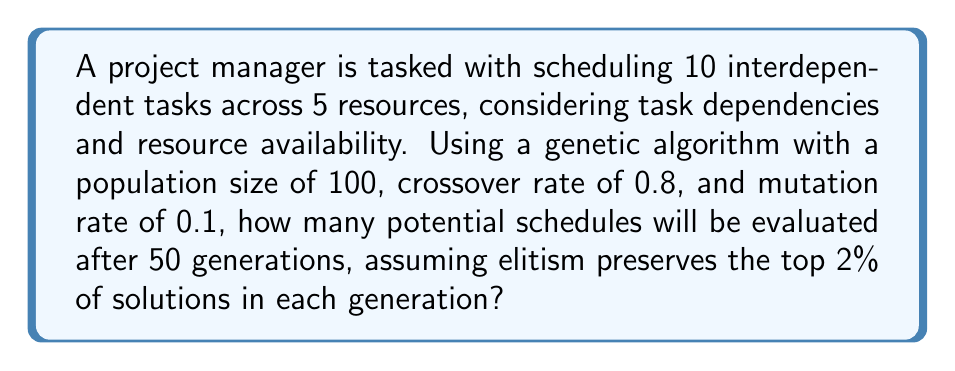Can you solve this math problem? To solve this problem, we'll follow these steps:

1. Calculate the number of new individuals created in each generation:
   - Population size = 100
   - Elitism rate = 2% = 0.02
   - Number of elite individuals = $100 * 0.02 = 2$
   - New individuals per generation = $100 - 2 = 98$

2. Calculate the total number of new individuals over 50 generations:
   $$ \text{Total new individuals} = 98 * 50 = 4900 $$

3. Add the initial population to the total:
   $$ \text{Total evaluated schedules} = 4900 + 100 = 5000 $$

4. Account for the elite individuals being carried over:
   - Elite individuals per generation = 2
   - Number of generations = 50
   - Total elite evaluations = $2 * 50 = 100$

5. Sum up the total number of schedule evaluations:
   $$ \text{Final total} = 5000 + 100 = 5100 $$

Therefore, after 50 generations, the genetic algorithm will have evaluated 5100 potential schedules.
Answer: 5100 schedules 